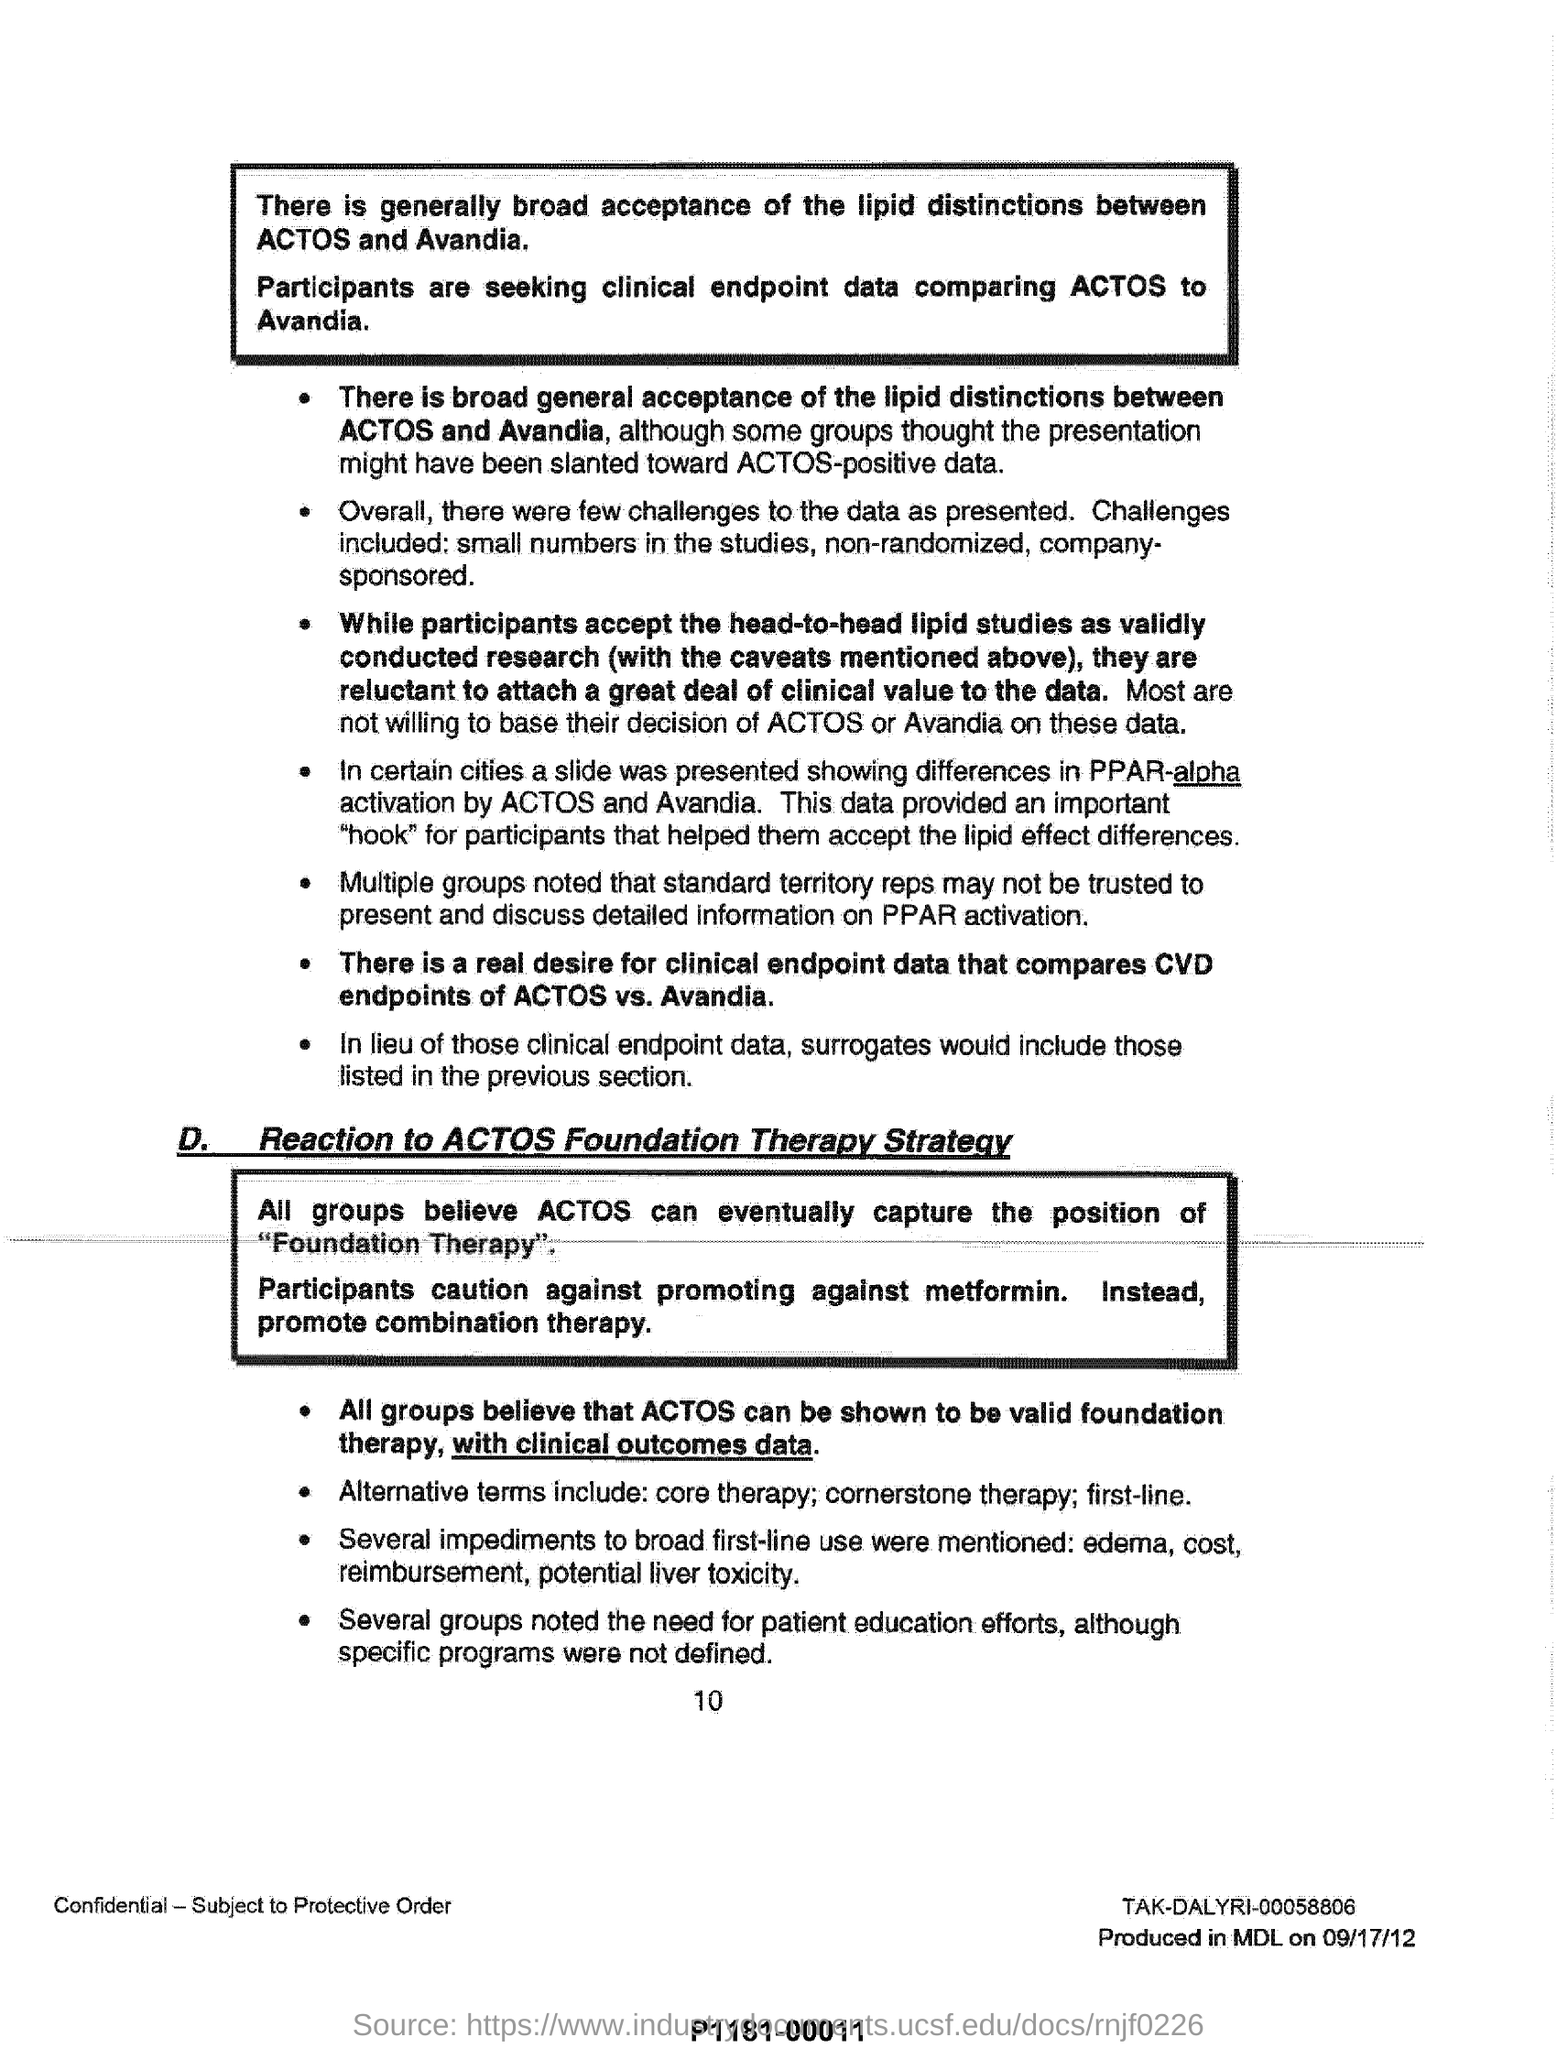Give some essential details in this illustration. Alternate terms for substance abuse treatment may include core therapy, cornerstone therapy, and first-line therapy. The findings of the ACTOS studies, which included small sample sizes, non-randomized design, and company sponsorship, presented several challenges in interpreting the positive results. 